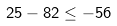Convert formula to latex. <formula><loc_0><loc_0><loc_500><loc_500>2 5 - 8 2 \leq - 5 6</formula> 